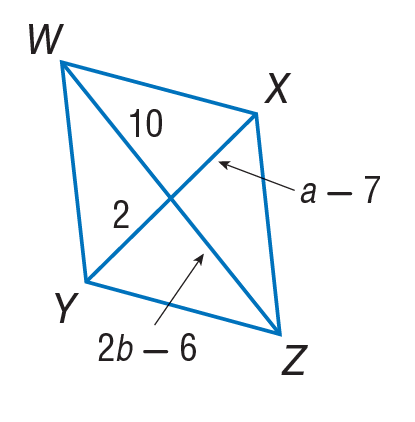Answer the mathemtical geometry problem and directly provide the correct option letter.
Question: Find b in the given parallelogram.
Choices: A: 2 B: 8 C: 9 D: 10 B 